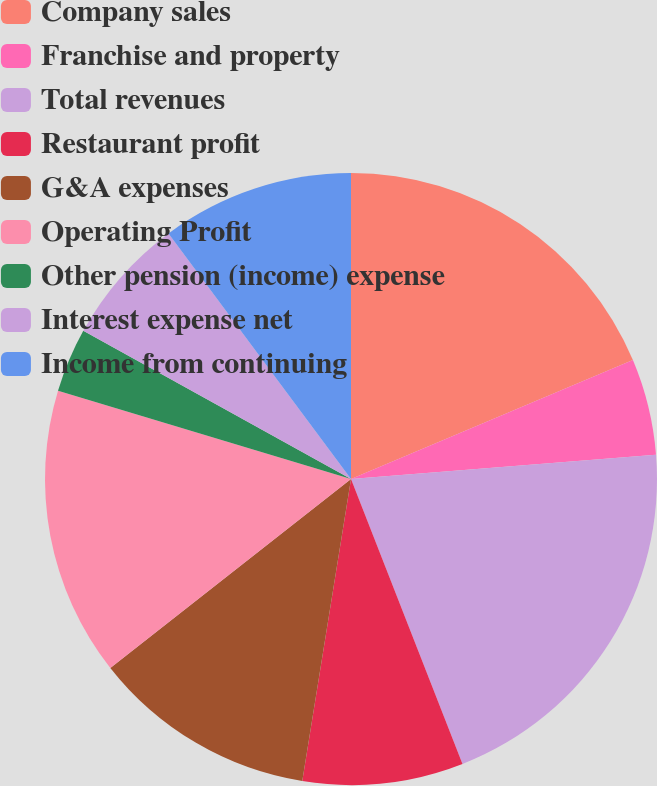Convert chart to OTSL. <chart><loc_0><loc_0><loc_500><loc_500><pie_chart><fcel>Company sales<fcel>Franchise and property<fcel>Total revenues<fcel>Restaurant profit<fcel>G&A expenses<fcel>Operating Profit<fcel>Other pension (income) expense<fcel>Interest expense net<fcel>Income from continuing<nl><fcel>18.64%<fcel>5.09%<fcel>20.33%<fcel>8.48%<fcel>11.86%<fcel>15.25%<fcel>3.39%<fcel>6.78%<fcel>10.17%<nl></chart> 